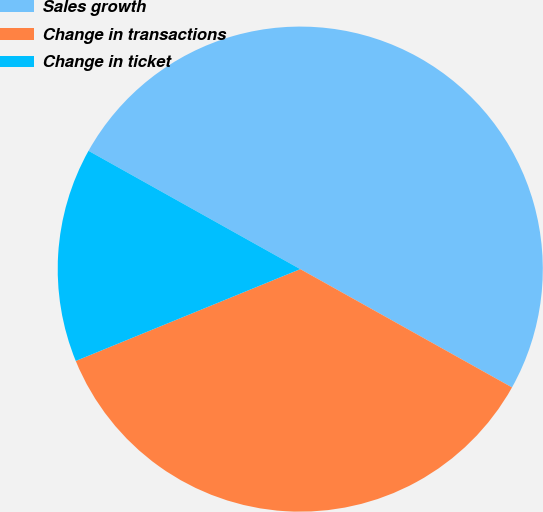Convert chart to OTSL. <chart><loc_0><loc_0><loc_500><loc_500><pie_chart><fcel>Sales growth<fcel>Change in transactions<fcel>Change in ticket<nl><fcel>50.0%<fcel>35.71%<fcel>14.29%<nl></chart> 